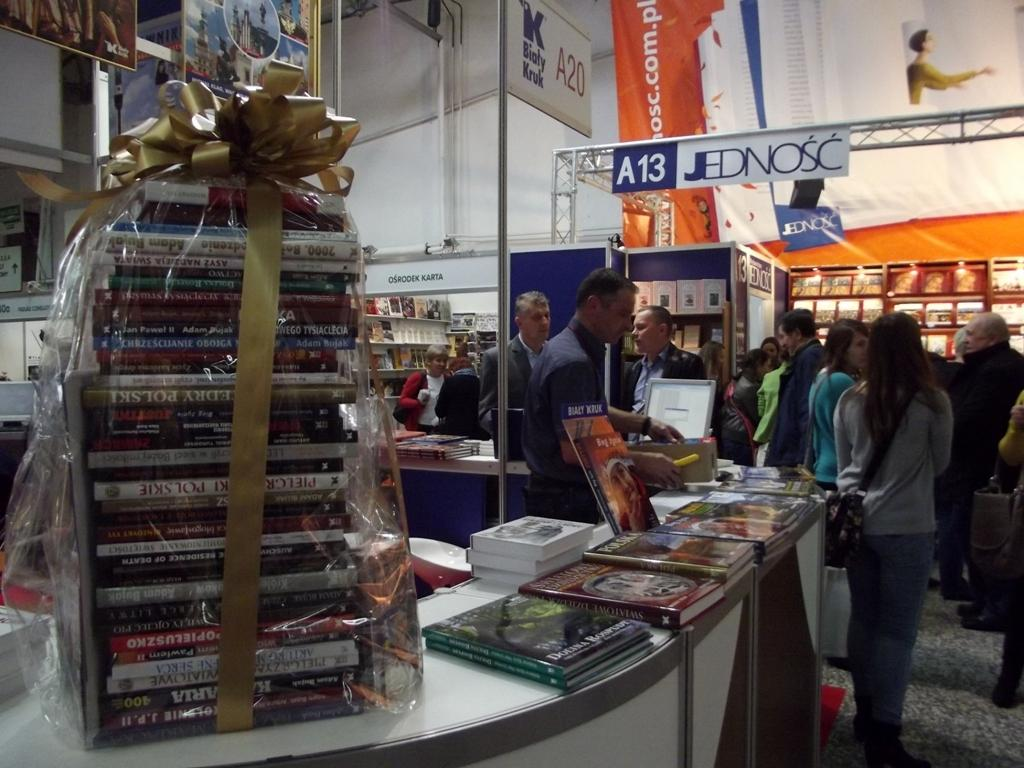<image>
Describe the image concisely. A store called Jednosc has books wrapped in cellophane and a gold ribbon on top on the counter 